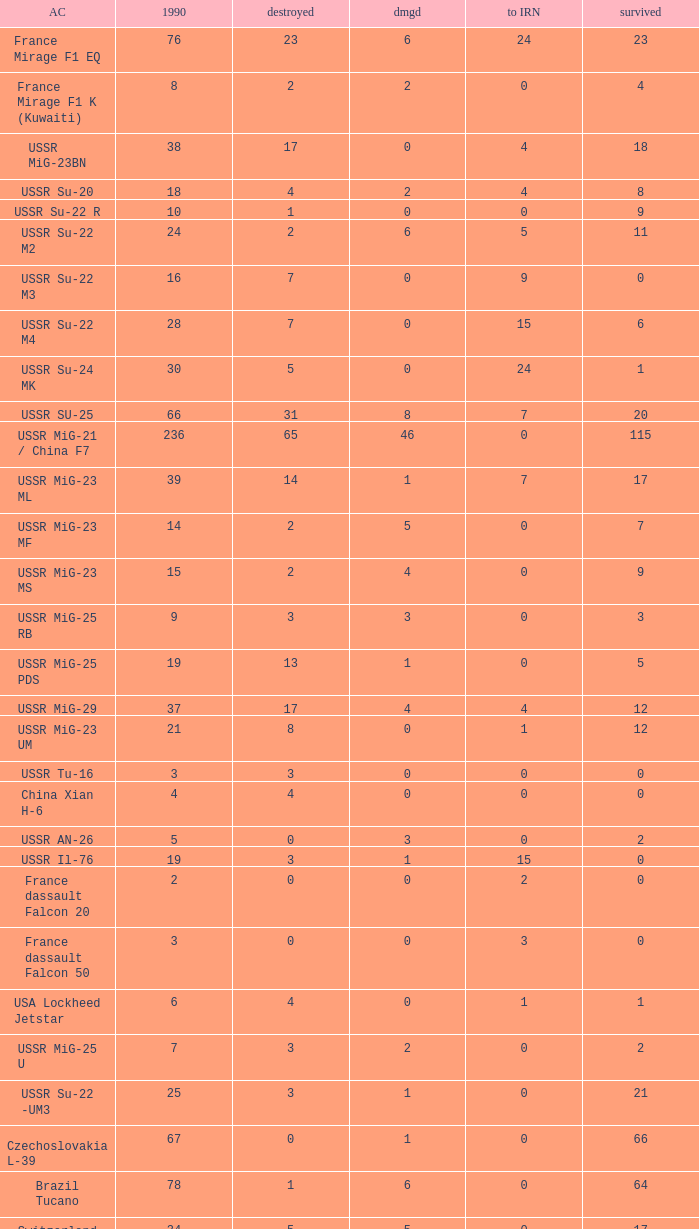If the aircraft was  ussr mig-25 rb how many were destroyed? 3.0. 